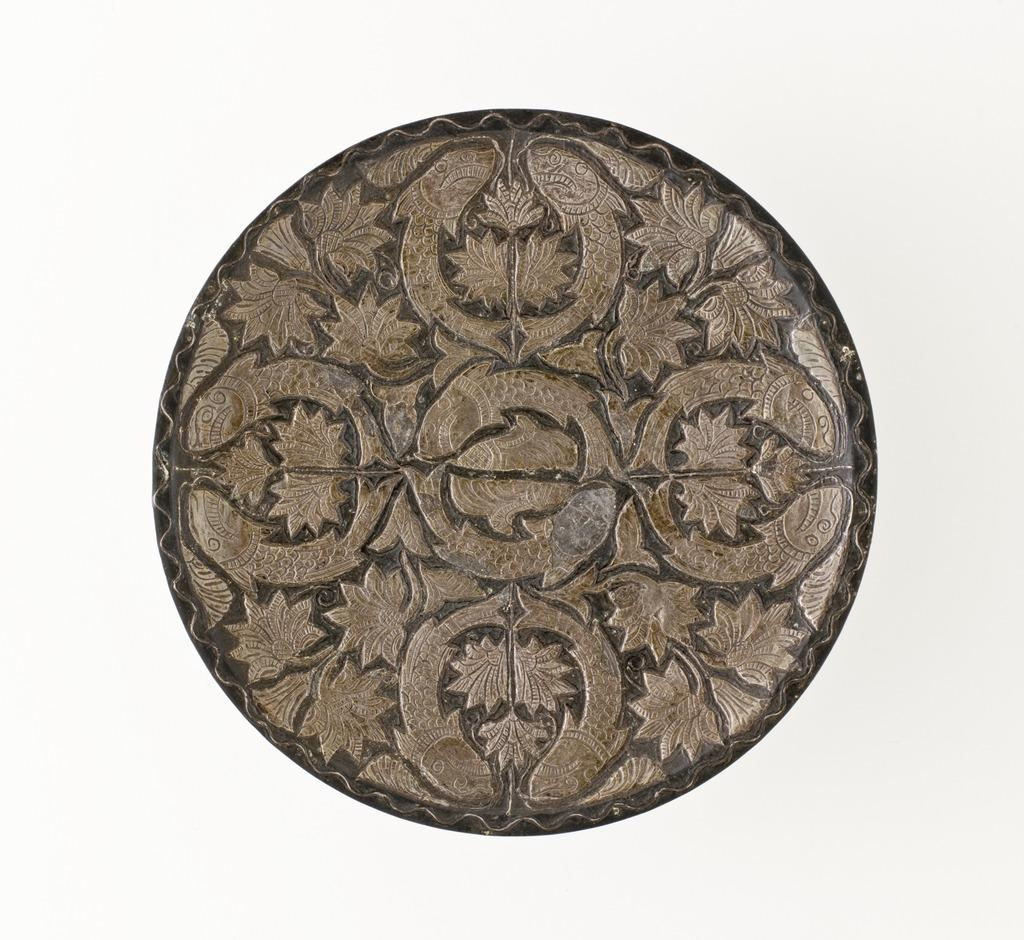What shape is the main object in the image? The main object in the image is circular. What can be observed about the design of the circular object? The circular object has golden color designs. What color is the background of the image? The background of the image is white. How many pests can be seen crawling on the circular object in the image? There are no pests present in the image; it only features a circular object with golden color designs against a white background. 